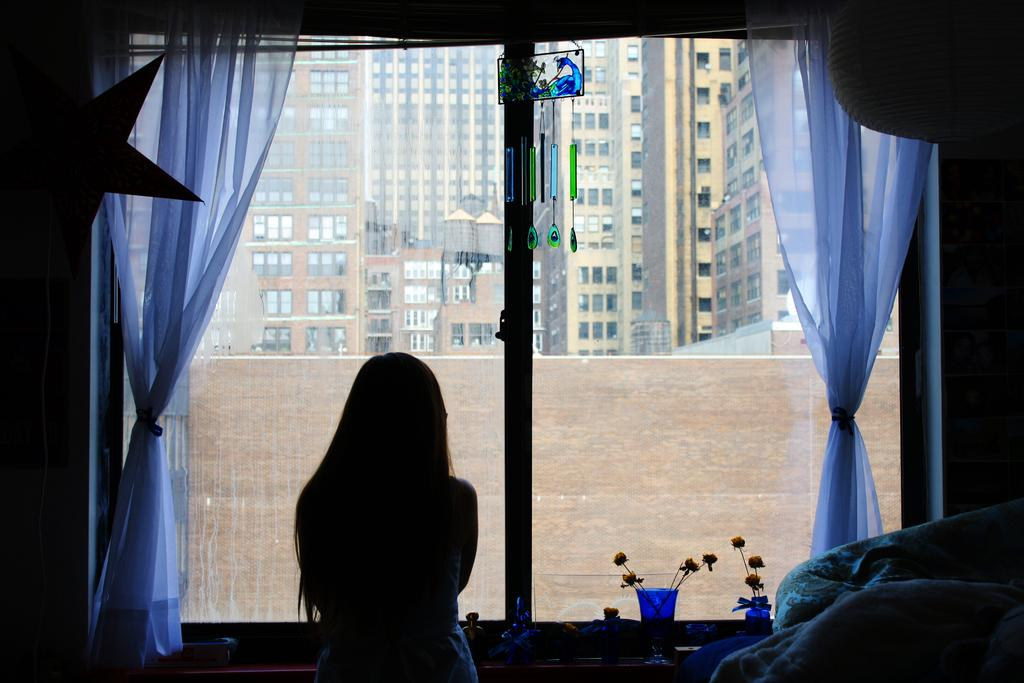What is the main subject in the image? There is a person standing in the image. What can be seen on the windowsill in the image? There are flowers in glasses in the image. What type of window treatment is present in the image? There are curtains in the image. What is visible through the window in the image? There is a window in the image, and buildings can be seen in the background. How many jellyfish are swimming in the window in the image? There are no jellyfish present in the image; the window shows buildings in the background. 